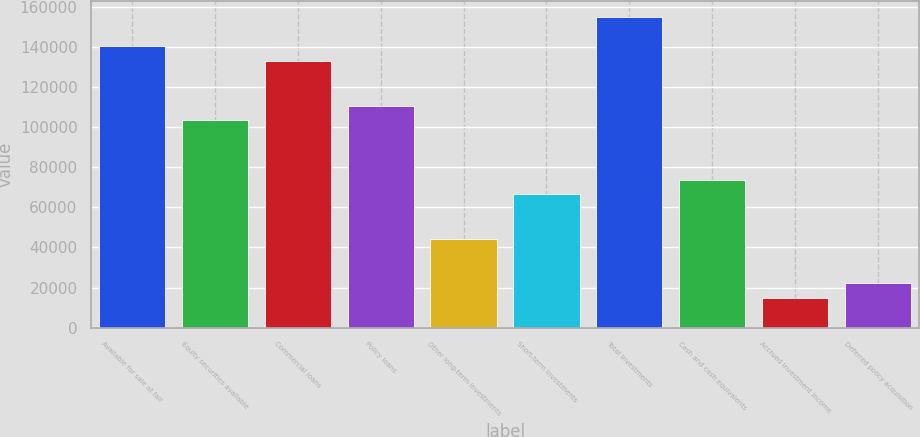Convert chart to OTSL. <chart><loc_0><loc_0><loc_500><loc_500><bar_chart><fcel>Available for sale at fair<fcel>Equity securities available<fcel>Commercial loans<fcel>Policy loans<fcel>Other long-term investments<fcel>Short-term investments<fcel>Total investments<fcel>Cash and cash equivalents<fcel>Accrued investment income<fcel>Deferred policy acquisition<nl><fcel>140177<fcel>103291<fcel>132800<fcel>110668<fcel>44274.6<fcel>66405.9<fcel>154931<fcel>73783<fcel>14766.2<fcel>22143.3<nl></chart> 